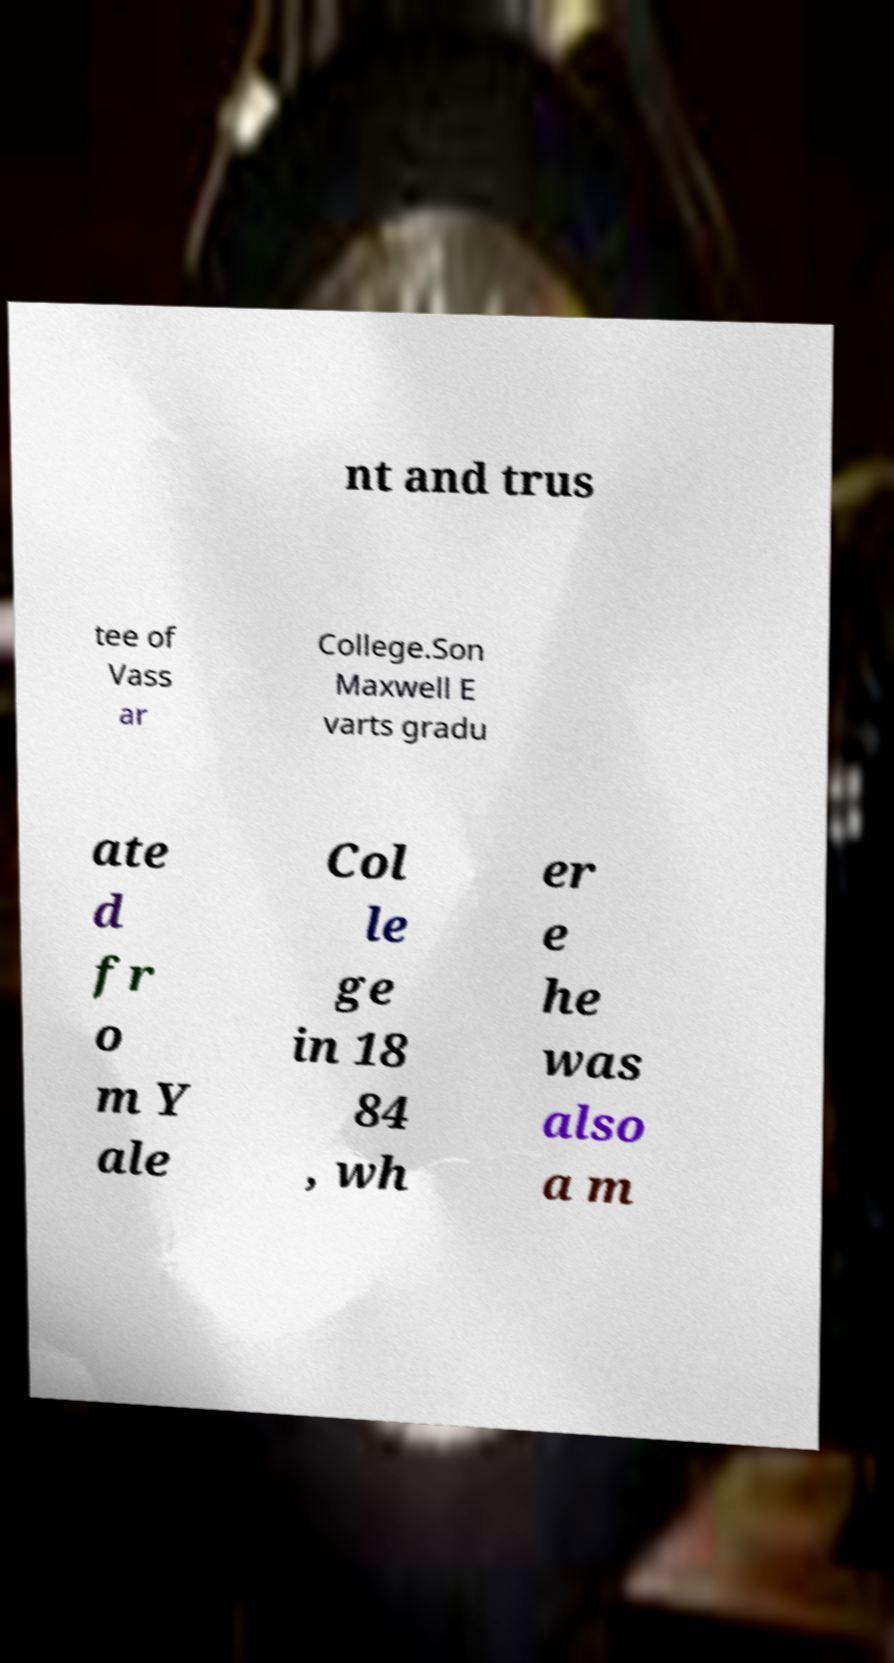For documentation purposes, I need the text within this image transcribed. Could you provide that? nt and trus tee of Vass ar College.Son Maxwell E varts gradu ate d fr o m Y ale Col le ge in 18 84 , wh er e he was also a m 